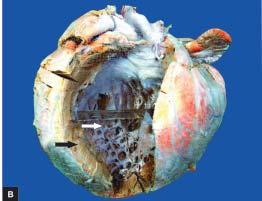what is thickened hypertrophy with dilatation?
Answer the question using a single word or phrase. Free left ventricular wall 